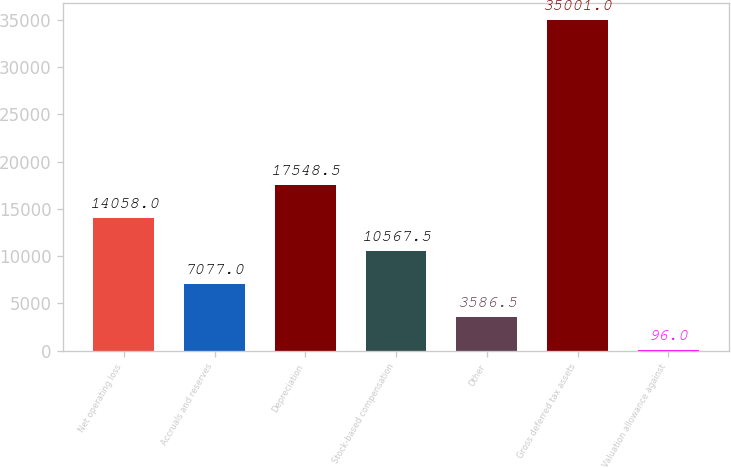Convert chart to OTSL. <chart><loc_0><loc_0><loc_500><loc_500><bar_chart><fcel>Net operating loss<fcel>Accruals and reserves<fcel>Depreciation<fcel>Stock-based compensation<fcel>Other<fcel>Gross deferred tax assets<fcel>Valuation allowance against<nl><fcel>14058<fcel>7077<fcel>17548.5<fcel>10567.5<fcel>3586.5<fcel>35001<fcel>96<nl></chart> 